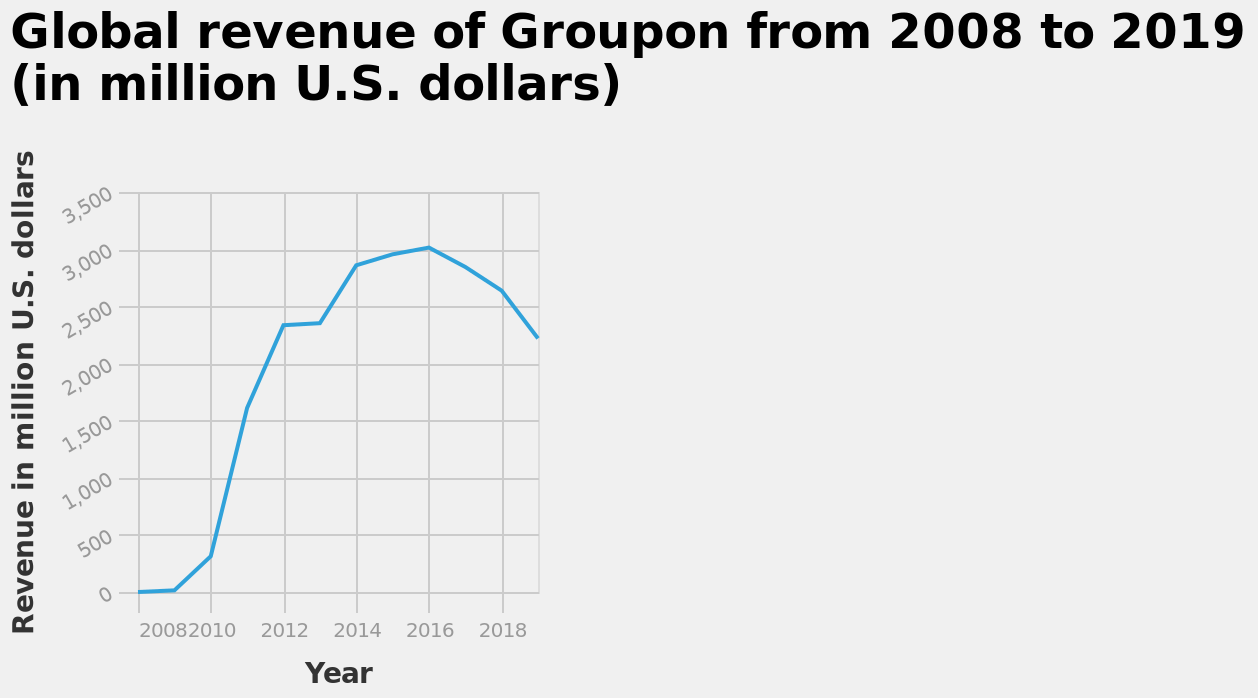<image>
Did Groupon's revenue continue to rise after 2016?  No, Groupon's revenue started to decline after 2016. When did Groupon's revenue begin to fall again?  Groupon's revenue started declining after 2016. What is the range of revenue indicated on the y-axis of the line diagram?  The range of revenue indicated on the y-axis of the line diagram is from $0 million to $3,500 million. Offer a thorough analysis of the image. Groupon revenue made a sharp rise from 2010-16 before beginning to fall again. Is there a consistent upward or downward trend in Groupon's revenue from 2008 to 2019?  It cannot be determined from the given information as the line diagram does not provide a clear trend. 